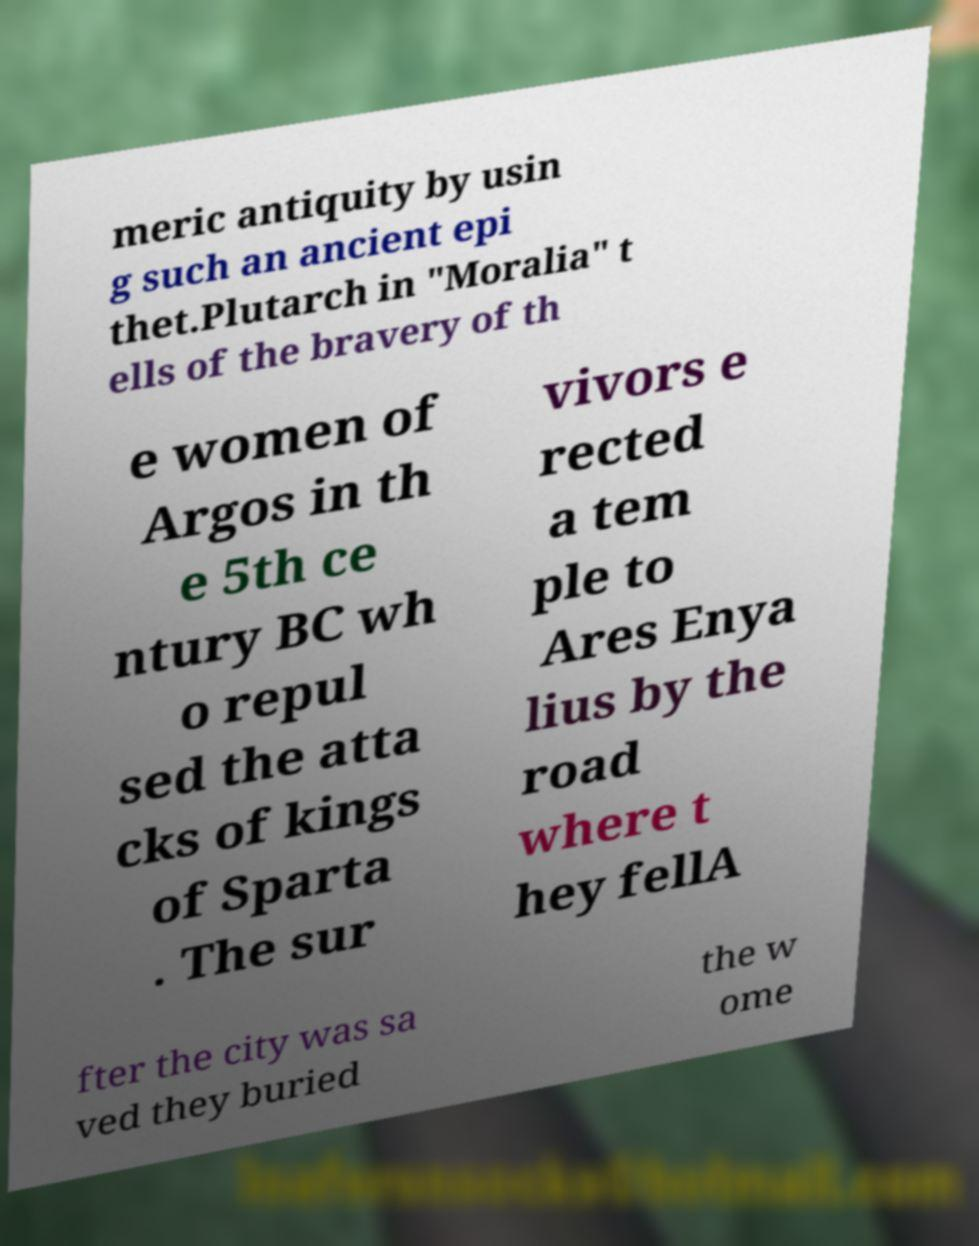Can you accurately transcribe the text from the provided image for me? meric antiquity by usin g such an ancient epi thet.Plutarch in "Moralia" t ells of the bravery of th e women of Argos in th e 5th ce ntury BC wh o repul sed the atta cks of kings of Sparta . The sur vivors e rected a tem ple to Ares Enya lius by the road where t hey fellA fter the city was sa ved they buried the w ome 